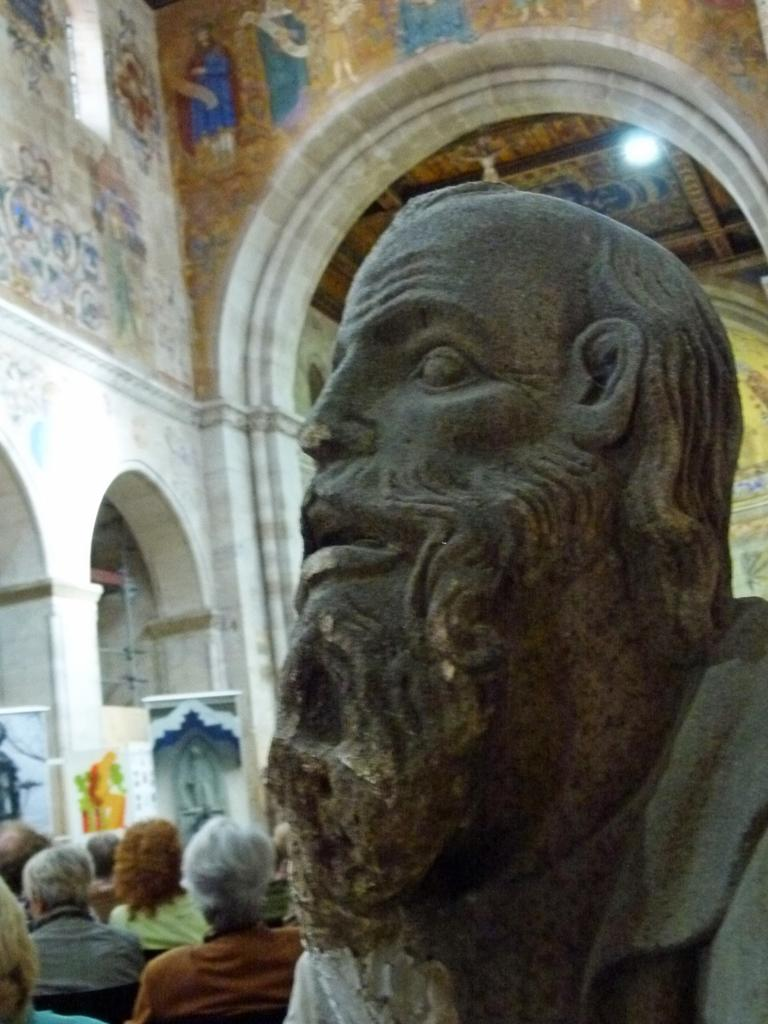What is located on the right side of the image? There is a statue on the right side of the image. What can be seen in the background of the image? There are persons, pillars, light, and a wall visible in the background of the image. What type of chin can be seen on the statue in the image? There is no chin visible on the statue in the image, as it is a statue and does not have facial features. 